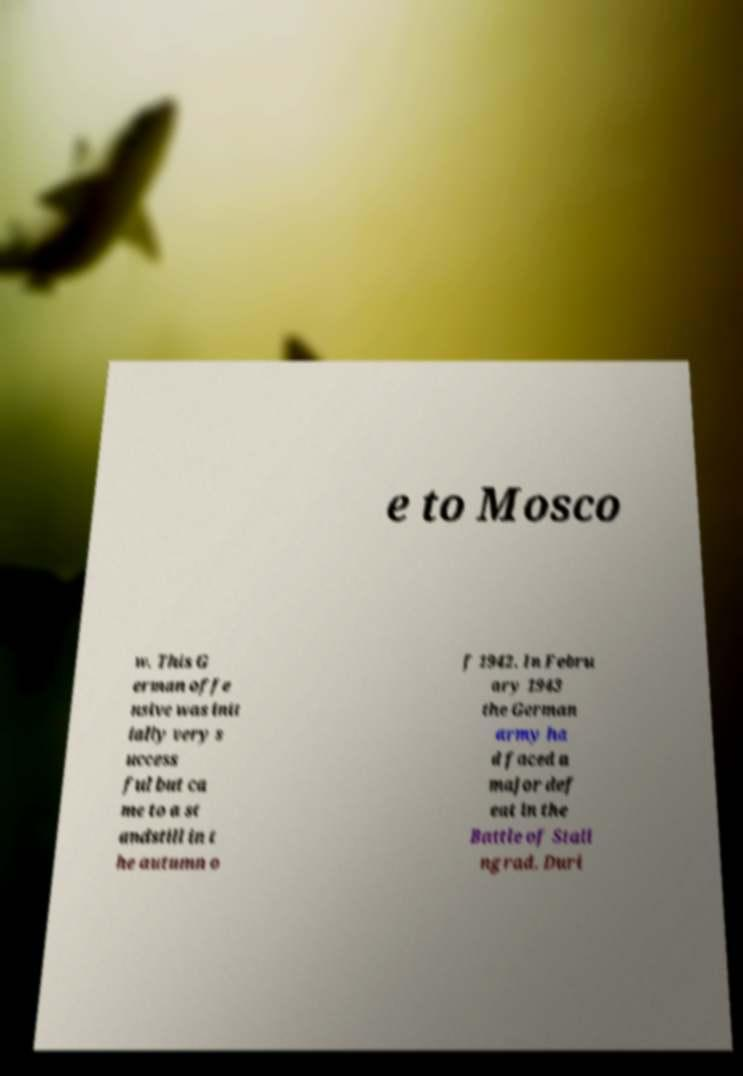Can you accurately transcribe the text from the provided image for me? e to Mosco w. This G erman offe nsive was init ially very s uccess ful but ca me to a st andstill in t he autumn o f 1942. In Febru ary 1943 the German army ha d faced a major def eat in the Battle of Stali ngrad. Duri 